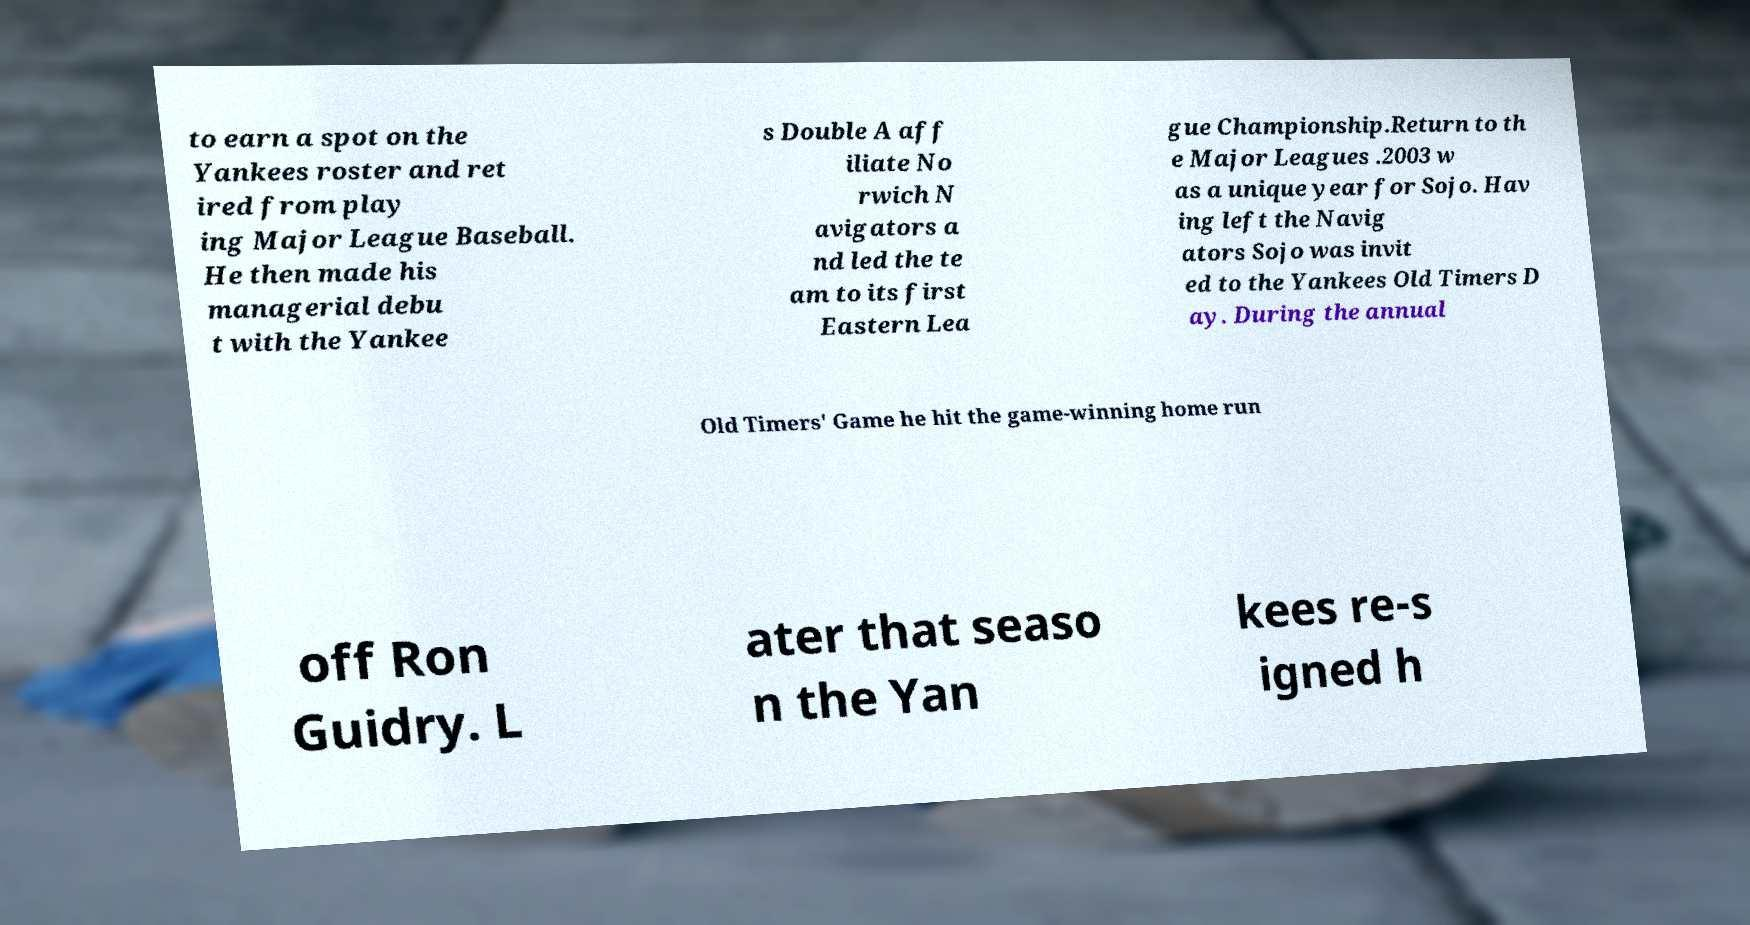Please read and relay the text visible in this image. What does it say? to earn a spot on the Yankees roster and ret ired from play ing Major League Baseball. He then made his managerial debu t with the Yankee s Double A aff iliate No rwich N avigators a nd led the te am to its first Eastern Lea gue Championship.Return to th e Major Leagues .2003 w as a unique year for Sojo. Hav ing left the Navig ators Sojo was invit ed to the Yankees Old Timers D ay. During the annual Old Timers' Game he hit the game-winning home run off Ron Guidry. L ater that seaso n the Yan kees re-s igned h 